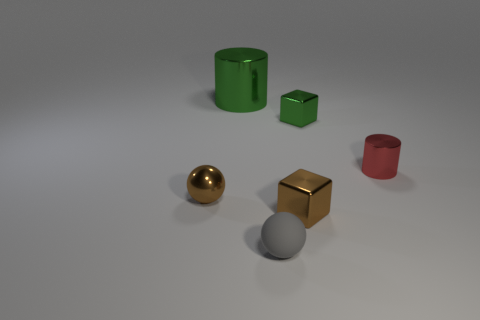There is a ball left of the large green object; what material is it?
Provide a short and direct response. Metal. There is a shiny object that is both in front of the green metallic cylinder and on the left side of the tiny matte sphere; what is its color?
Your answer should be compact. Brown. How many other objects are the same color as the shiny sphere?
Offer a terse response. 1. The metal cylinder on the left side of the small rubber thing is what color?
Give a very brief answer. Green. Are there any yellow matte balls that have the same size as the green cube?
Keep it short and to the point. No. There is a brown cube that is the same size as the red shiny object; what is its material?
Your answer should be very brief. Metal. How many things are small objects behind the brown shiny sphere or small metallic things that are to the right of the gray thing?
Make the answer very short. 3. Are there any other matte objects of the same shape as the large green object?
Your answer should be very brief. No. There is a block that is the same color as the big cylinder; what is its material?
Ensure brevity in your answer.  Metal. How many metallic things are cubes or tiny spheres?
Provide a succinct answer. 3. 